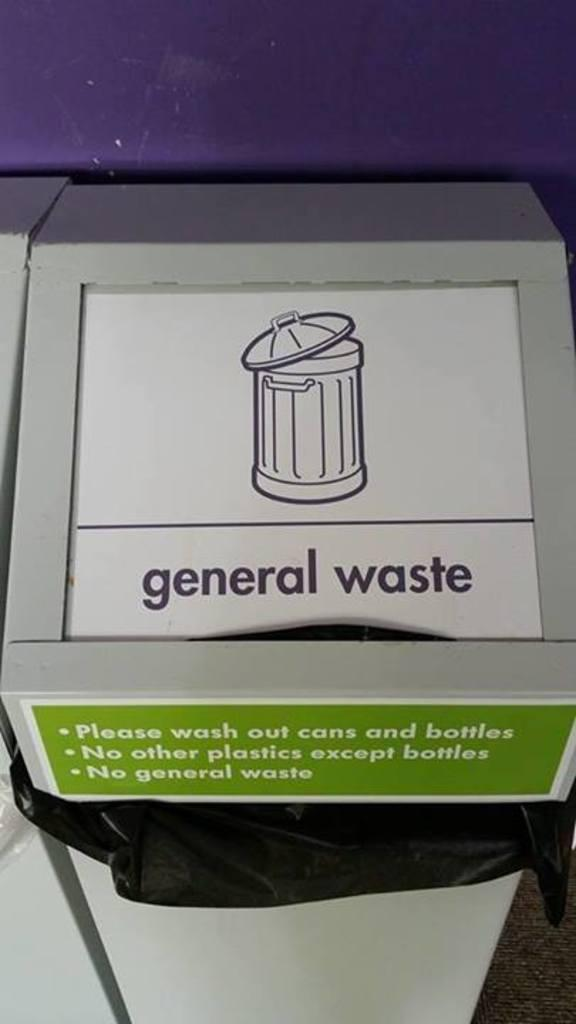<image>
Render a clear and concise summary of the photo. A general waste trash can sits against a purple wall 